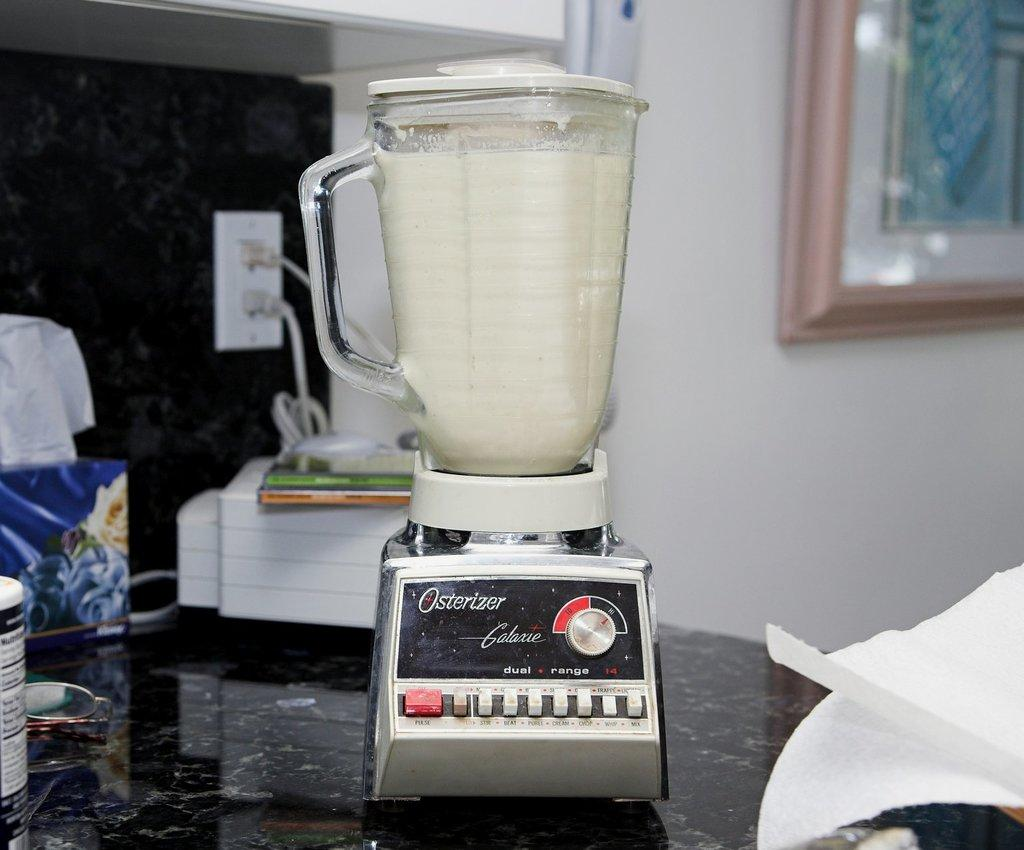Provide a one-sentence caption for the provided image. An Osterizer blender full of a white liquid on a counter. 